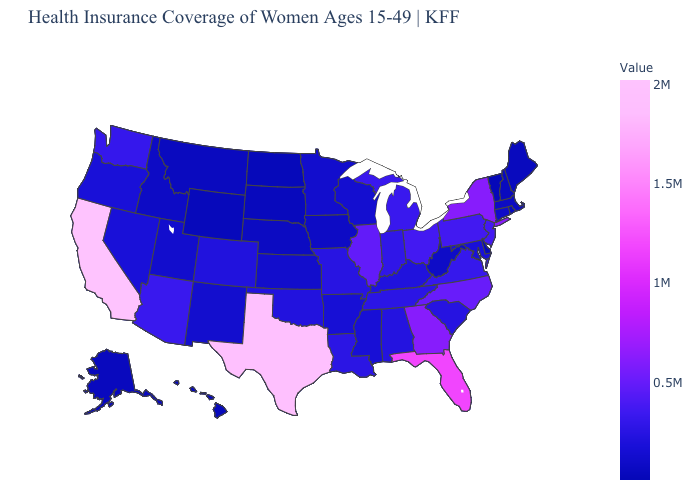Among the states that border Connecticut , does New York have the highest value?
Short answer required. Yes. Does Indiana have a lower value than North Dakota?
Give a very brief answer. No. Does Vermont have the lowest value in the USA?
Be succinct. Yes. Does the map have missing data?
Quick response, please. No. Which states have the lowest value in the MidWest?
Keep it brief. North Dakota. Does California have the highest value in the USA?
Short answer required. Yes. Does the map have missing data?
Give a very brief answer. No. 